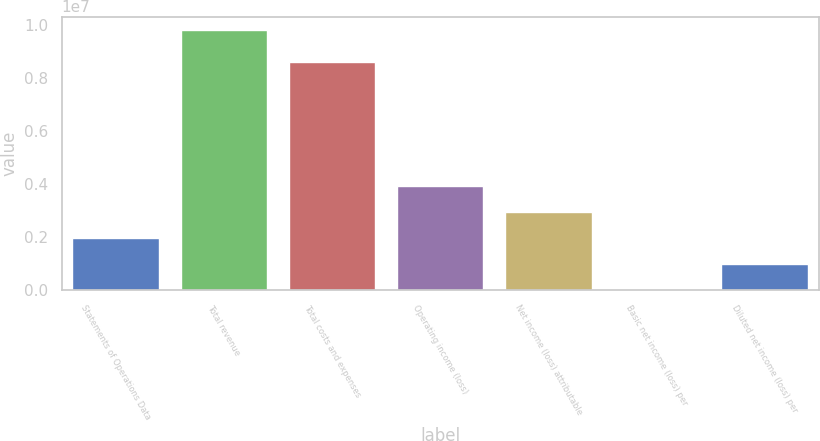Convert chart to OTSL. <chart><loc_0><loc_0><loc_500><loc_500><bar_chart><fcel>Statements of Operations Data<fcel>Total revenue<fcel>Total costs and expenses<fcel>Operating income (loss)<fcel>Net income (loss) attributable<fcel>Basic net income (loss) per<fcel>Diluted net income (loss) per<nl><fcel>1.9637e+06<fcel>9.81849e+06<fcel>8.60112e+06<fcel>3.9274e+06<fcel>2.94555e+06<fcel>1.37<fcel>981850<nl></chart> 